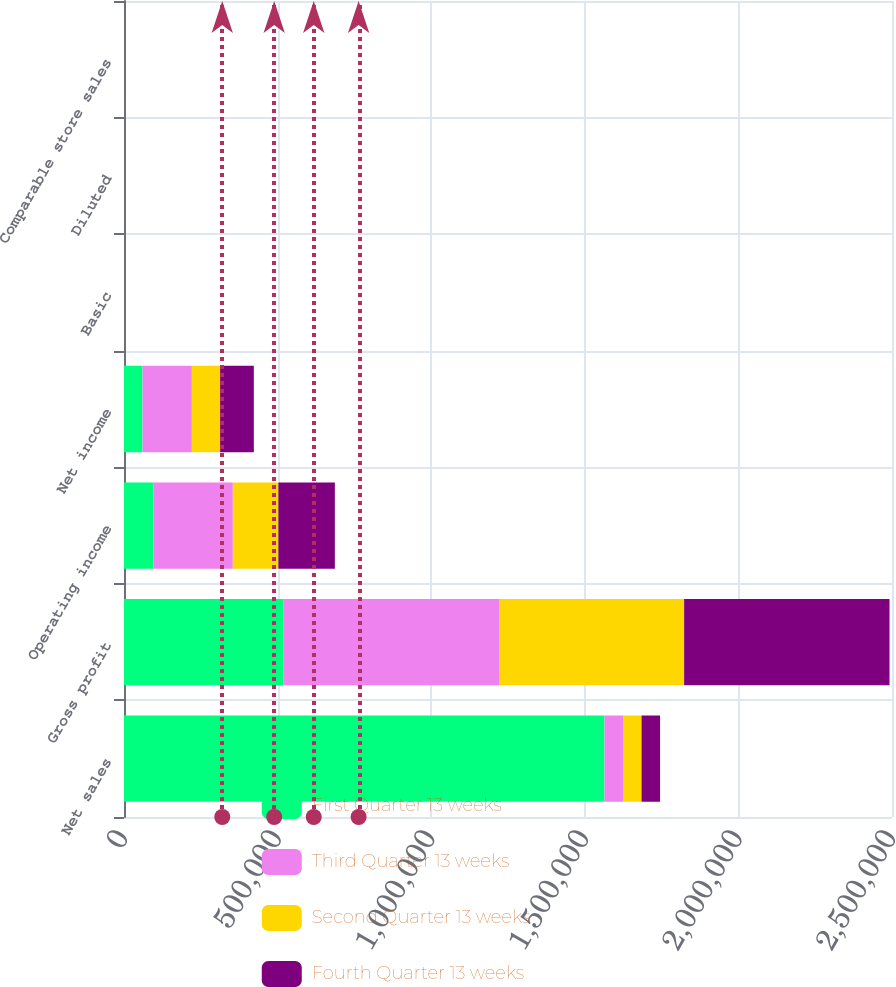Convert chart to OTSL. <chart><loc_0><loc_0><loc_500><loc_500><stacked_bar_chart><ecel><fcel>Net sales<fcel>Gross profit<fcel>Operating income<fcel>Net income<fcel>Basic<fcel>Diluted<fcel>Comparable store sales<nl><fcel>First Quarter 13 weeks<fcel>1.56408e+06<fcel>518203<fcel>96362<fcel>60311<fcel>0.46<fcel>0.46<fcel>2.2<nl><fcel>Third Quarter 13 weeks<fcel>60311<fcel>704708<fcel>257925<fcel>160649<fcel>1.25<fcel>1.25<fcel>2.2<nl><fcel>Second Quarter 13 weeks<fcel>60311<fcel>600456<fcel>148253<fcel>91896<fcel>0.73<fcel>0.72<fcel>6.6<nl><fcel>Fourth Quarter 13 weeks<fcel>60311<fcel>668598<fcel>183842<fcel>109743<fcel>0.87<fcel>0.87<fcel>4<nl></chart> 